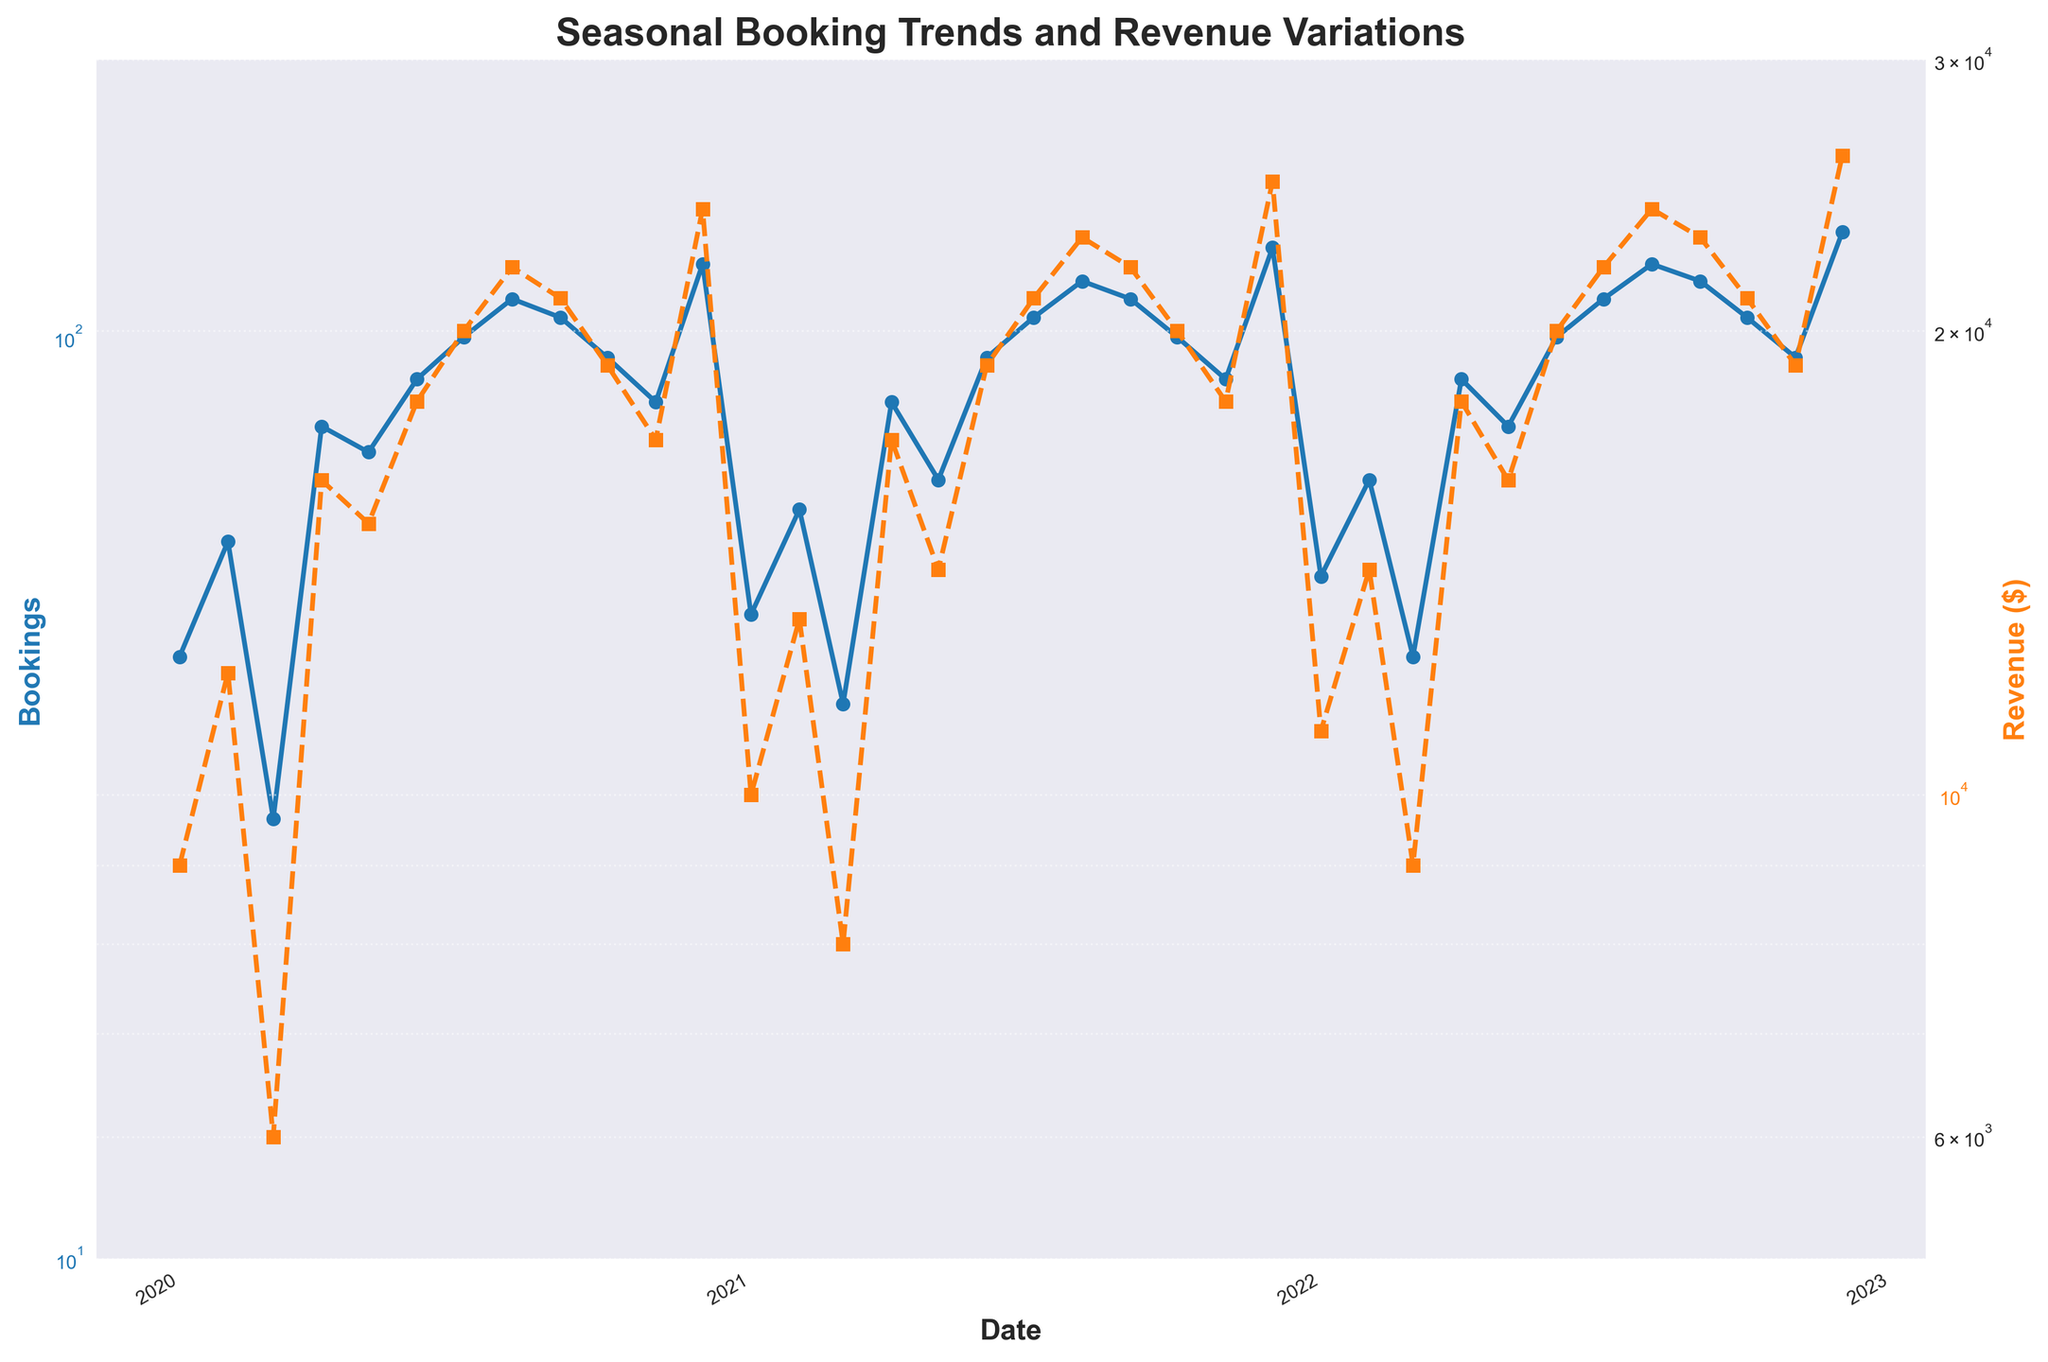What are the colors used for the lines representing Bookings and Revenue? The line for Bookings is colored blue and the line for Revenue is colored orange.
Answer: Blue and orange What is the title of the plot? The title is displayed at the top of the plot and reads "Seasonal Booking Trends and Revenue Variations".
Answer: Seasonal Booking Trends and Revenue Variations Which month in 2022 had the highest bookings, and what was the number of bookings? By examining the plot, it is clear that December 2022 had the highest number of bookings, which was 130.
Answer: December, 130 Is there any month where bookings declined but revenue increased compared to the previous month? By investigating the plot for patterns, it is noticeable that in April 2020, bookings slightly increased from March 2020, but revenue remained the same at $16,000. However, no month shows an inverse pattern where bookings decline but revenue increases.
Answer: No What is the general trend in bookings and revenue from January 2020 to December 2022? Both bookings and revenue show a general increasing trend over the period from January 2020 to December 2022.
Answer: Increasing How did bookings change between January 2020 and January 2021? Bookings increased from 45 in January 2020 to 50 in January 2021.
Answer: Increased by 5 What is the difference in revenue between July 2020 and July 2022? Revenue in July 2020 was $20,000, and in July 2022, it was $22,000. The difference is $22,000 - $20,000 = $2,000.
Answer: $2,000 Which year had the highest average monthly bookings? On average, each month's bookings for 2020, 2021, and 2022 are calculated and compared. The highest average monthly bookings are seen in 2022.
Answer: 2022 When was the largest monthly increase in bookings observed? By closely examining the trend lines, it is evident that the largest monthly increase in bookings was from March 2020 (30 bookings) to April 2020 (80 bookings).
Answer: April 2020 What are the axes scales set to? Both y-axes (for bookings and revenue) are set on a logarithmic scale, making it easier to observe trends and accommodations over a broad range of values.
Answer: Logarithmic scale 